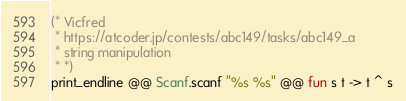<code> <loc_0><loc_0><loc_500><loc_500><_OCaml_>(* Vicfred
 * https://atcoder.jp/contests/abc149/tasks/abc149_a
 * string manipulation
 * *)
print_endline @@ Scanf.scanf "%s %s" @@ fun s t -> t ^ s

</code> 